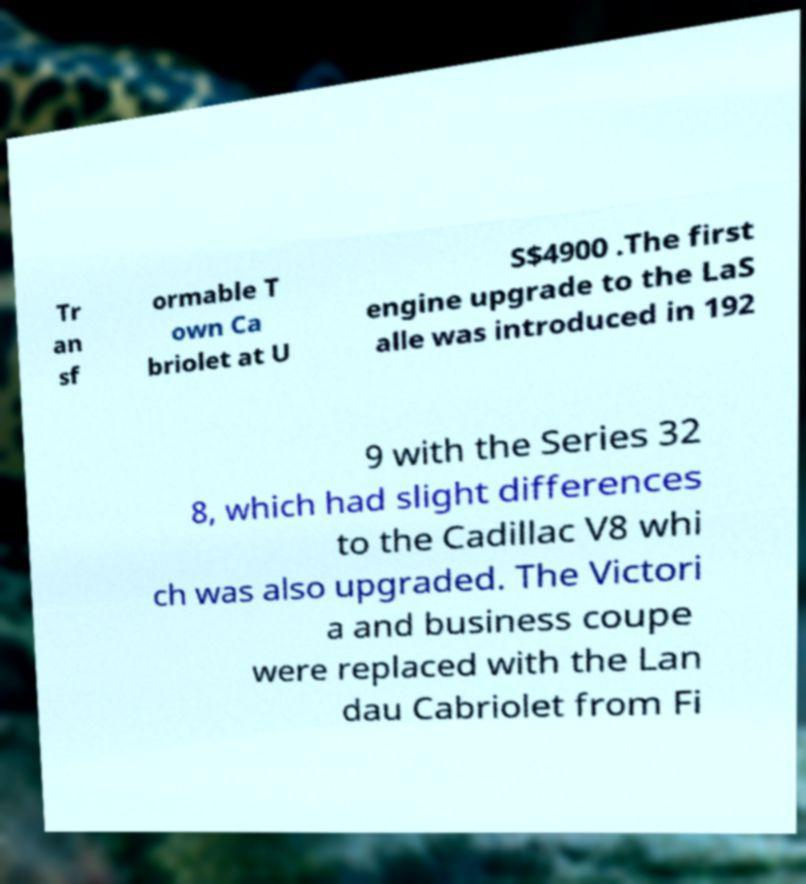I need the written content from this picture converted into text. Can you do that? Tr an sf ormable T own Ca briolet at U S$4900 .The first engine upgrade to the LaS alle was introduced in 192 9 with the Series 32 8, which had slight differences to the Cadillac V8 whi ch was also upgraded. The Victori a and business coupe were replaced with the Lan dau Cabriolet from Fi 